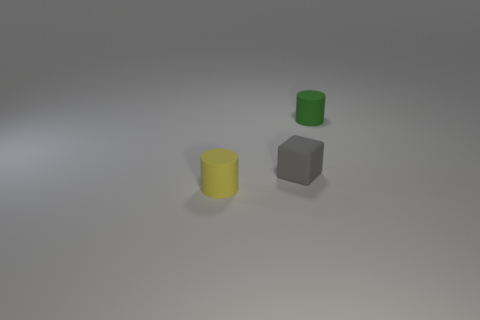The other object that is the same shape as the small green object is what color?
Provide a succinct answer. Yellow. There is a thing that is on the right side of the yellow thing and on the left side of the green matte cylinder; what is its material?
Keep it short and to the point. Rubber. Do the small cylinder to the left of the green cylinder and the cylinder behind the small yellow rubber thing have the same material?
Offer a terse response. Yes. The yellow object has what size?
Provide a short and direct response. Small. What size is the other thing that is the same shape as the tiny green thing?
Provide a succinct answer. Small. There is a matte block; how many yellow rubber cylinders are in front of it?
Your answer should be compact. 1. There is a tiny rubber cylinder behind the matte object that is to the left of the rubber block; what color is it?
Give a very brief answer. Green. Is there anything else that is the same shape as the yellow matte thing?
Offer a terse response. Yes. Are there the same number of things in front of the small yellow matte object and tiny rubber cubes that are in front of the gray rubber cube?
Your response must be concise. Yes. How many spheres are either gray matte things or large red things?
Provide a short and direct response. 0. 